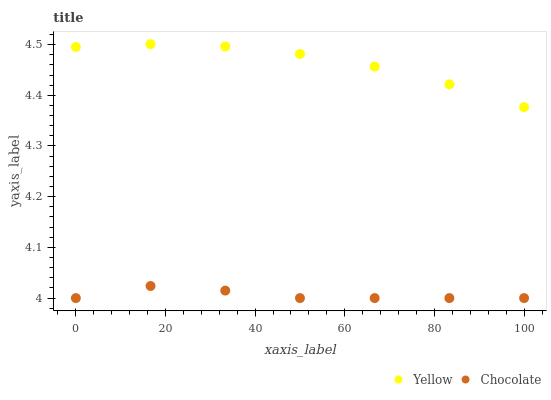Does Chocolate have the minimum area under the curve?
Answer yes or no. Yes. Does Yellow have the maximum area under the curve?
Answer yes or no. Yes. Does Chocolate have the maximum area under the curve?
Answer yes or no. No. Is Yellow the smoothest?
Answer yes or no. Yes. Is Chocolate the roughest?
Answer yes or no. Yes. Is Chocolate the smoothest?
Answer yes or no. No. Does Chocolate have the lowest value?
Answer yes or no. Yes. Does Yellow have the highest value?
Answer yes or no. Yes. Does Chocolate have the highest value?
Answer yes or no. No. Is Chocolate less than Yellow?
Answer yes or no. Yes. Is Yellow greater than Chocolate?
Answer yes or no. Yes. Does Chocolate intersect Yellow?
Answer yes or no. No. 